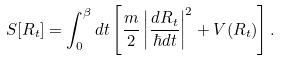Convert formula to latex. <formula><loc_0><loc_0><loc_500><loc_500>S [ R _ { t } ] = \int _ { 0 } ^ { \beta } d t \left [ \frac { m } { 2 } \left | \frac { d R _ { t } } { \hbar { d } t } \right | ^ { 2 } + V ( R _ { t } ) \right ] .</formula> 